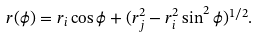Convert formula to latex. <formula><loc_0><loc_0><loc_500><loc_500>r ( \phi ) = r _ { i } \cos \phi + ( r _ { j } ^ { 2 } - r _ { i } ^ { 2 } \sin ^ { 2 } \phi ) ^ { 1 / 2 } .</formula> 